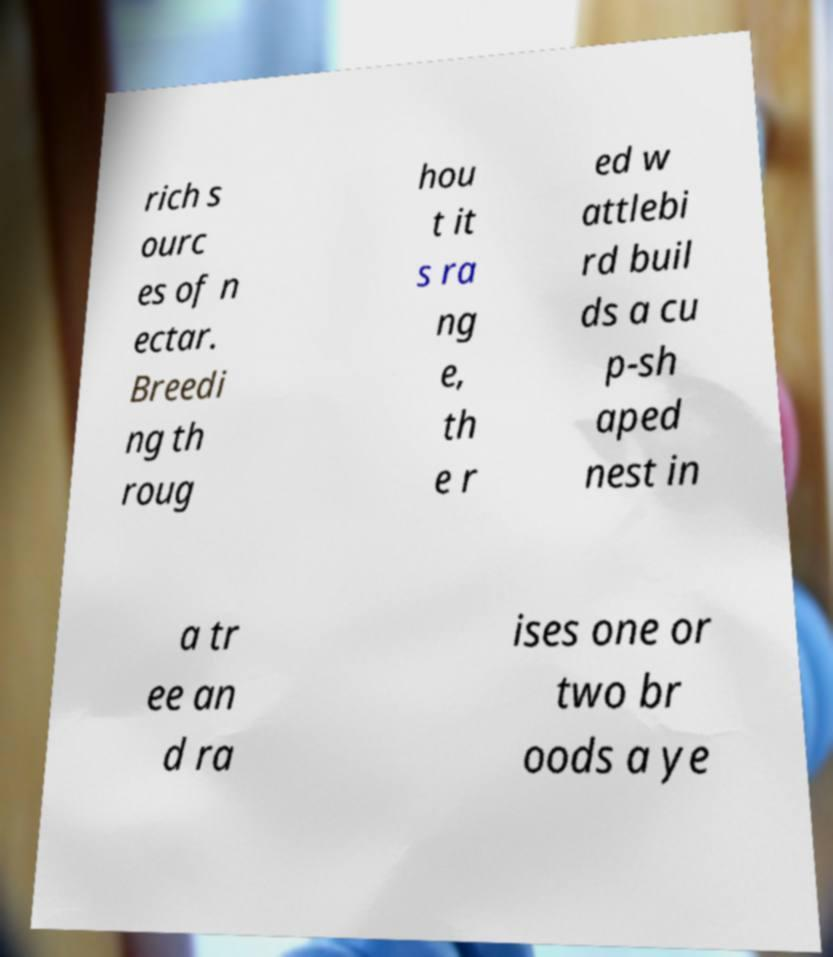I need the written content from this picture converted into text. Can you do that? rich s ourc es of n ectar. Breedi ng th roug hou t it s ra ng e, th e r ed w attlebi rd buil ds a cu p-sh aped nest in a tr ee an d ra ises one or two br oods a ye 